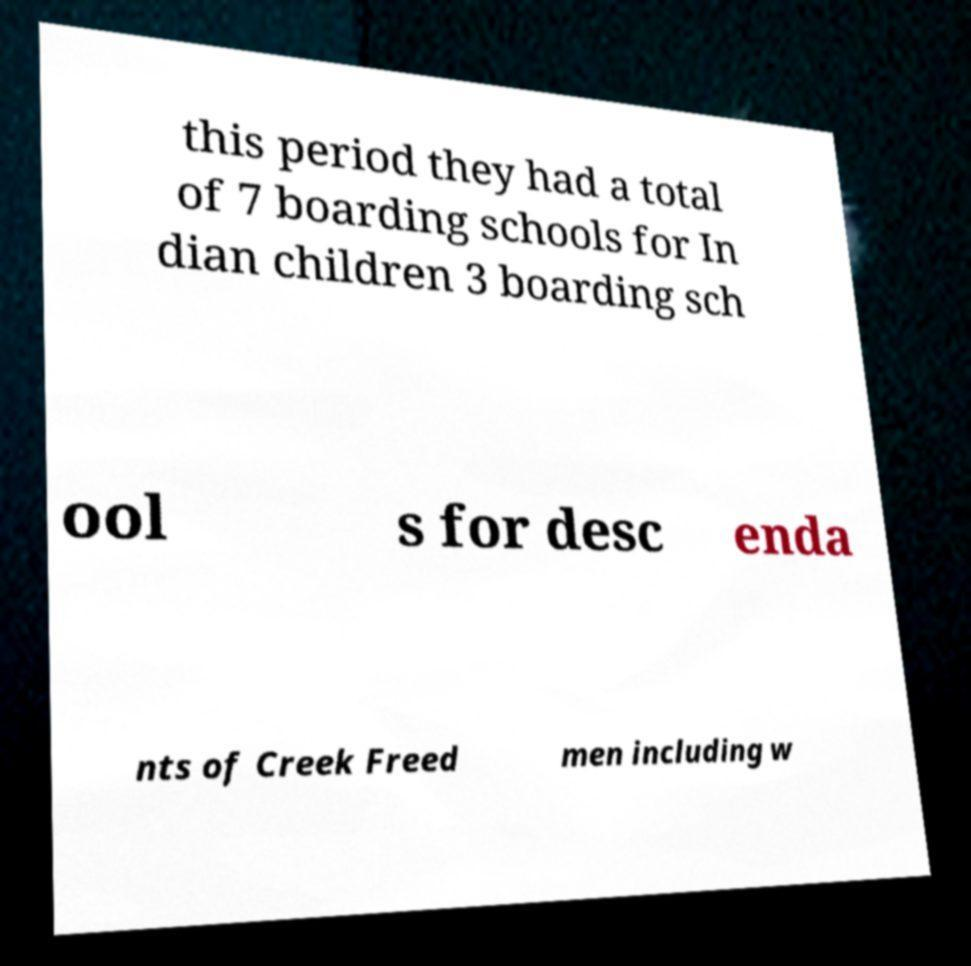Can you accurately transcribe the text from the provided image for me? this period they had a total of 7 boarding schools for In dian children 3 boarding sch ool s for desc enda nts of Creek Freed men including w 